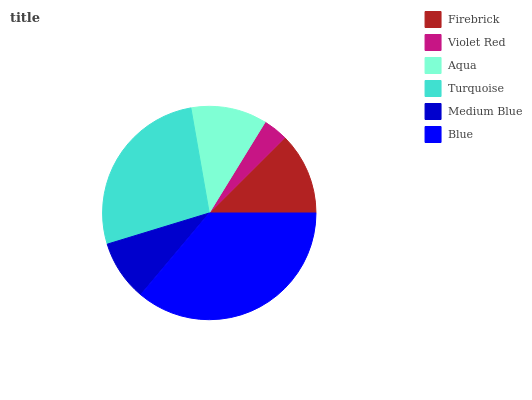Is Violet Red the minimum?
Answer yes or no. Yes. Is Blue the maximum?
Answer yes or no. Yes. Is Aqua the minimum?
Answer yes or no. No. Is Aqua the maximum?
Answer yes or no. No. Is Aqua greater than Violet Red?
Answer yes or no. Yes. Is Violet Red less than Aqua?
Answer yes or no. Yes. Is Violet Red greater than Aqua?
Answer yes or no. No. Is Aqua less than Violet Red?
Answer yes or no. No. Is Firebrick the high median?
Answer yes or no. Yes. Is Aqua the low median?
Answer yes or no. Yes. Is Violet Red the high median?
Answer yes or no. No. Is Turquoise the low median?
Answer yes or no. No. 